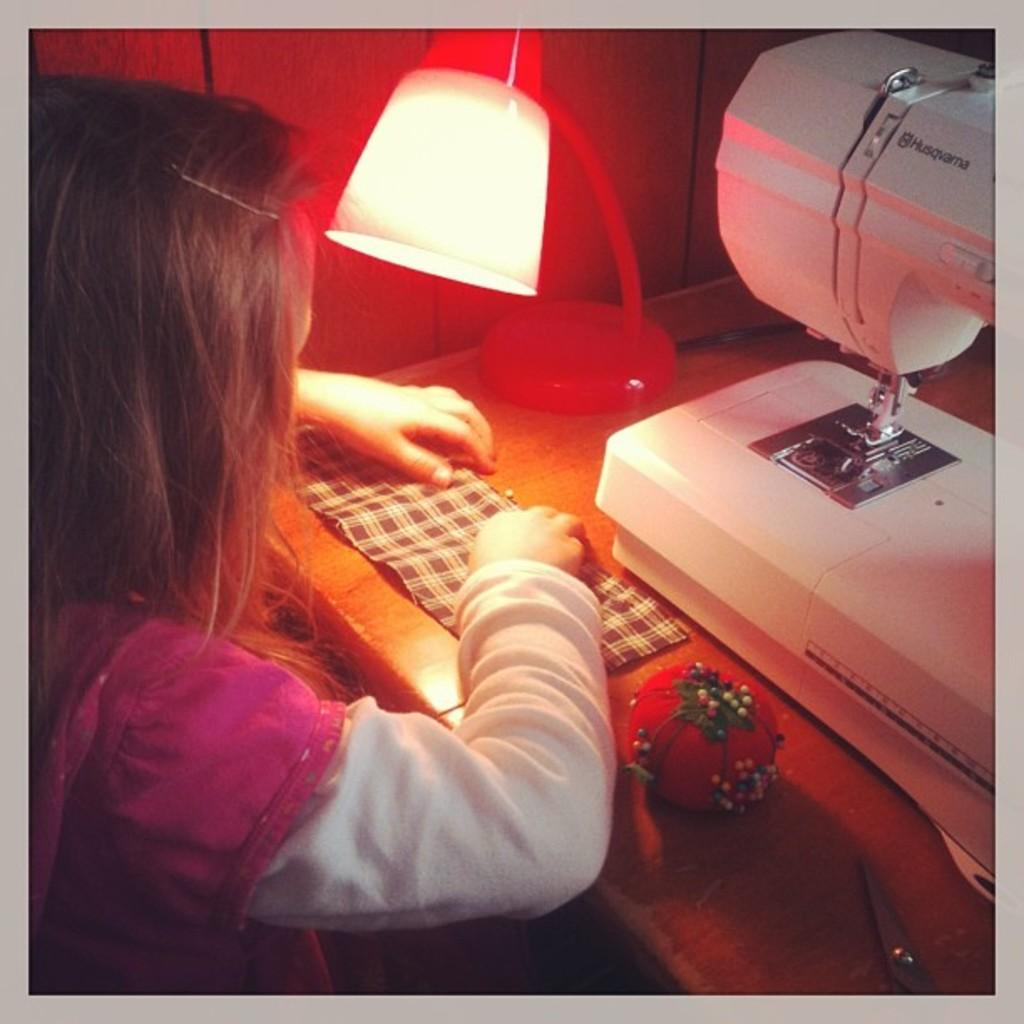Who is the main subject in the image? There is a girl in the image. What is the girl looking at? The girl is looking at a kloth. What other objects can be seen in the image? There is a lamp and a sewing machine on the right side of the image. Where are the fairies hiding in the image? There are no fairies present in the image. What type of art can be seen on the walls in the image? The image does not show any art on the walls. 